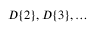Convert formula to latex. <formula><loc_0><loc_0><loc_500><loc_500>D \{ 2 \} , D \{ 3 \} , \dots</formula> 